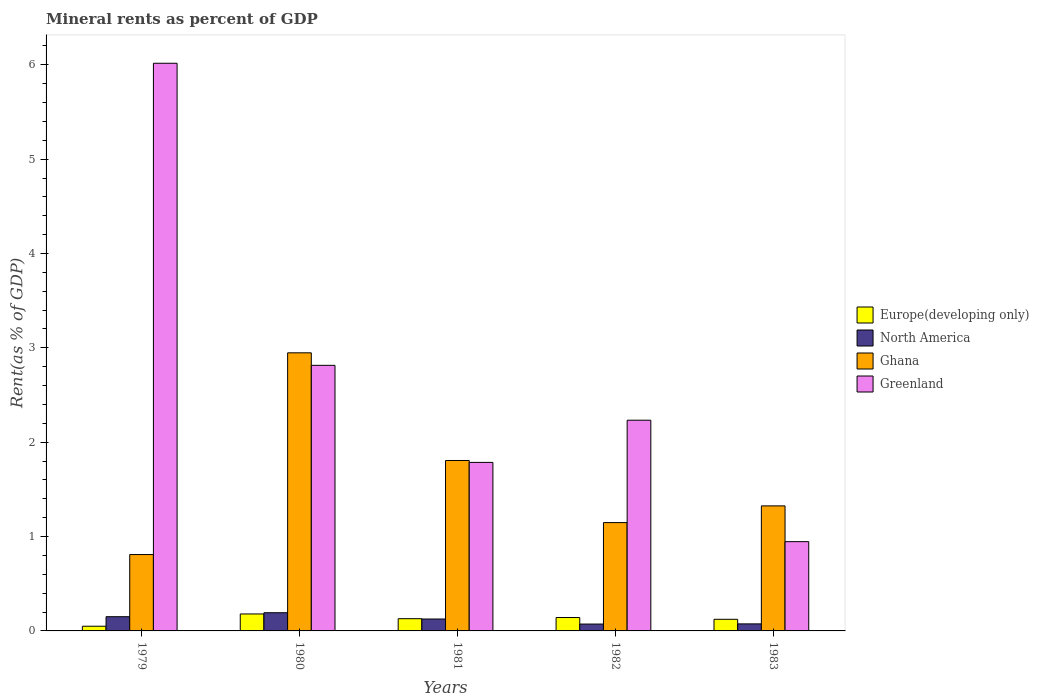How many groups of bars are there?
Keep it short and to the point. 5. How many bars are there on the 1st tick from the right?
Offer a terse response. 4. What is the mineral rent in North America in 1982?
Provide a succinct answer. 0.07. Across all years, what is the maximum mineral rent in Greenland?
Give a very brief answer. 6.02. Across all years, what is the minimum mineral rent in North America?
Ensure brevity in your answer.  0.07. In which year was the mineral rent in North America maximum?
Provide a succinct answer. 1980. In which year was the mineral rent in Europe(developing only) minimum?
Give a very brief answer. 1979. What is the total mineral rent in Ghana in the graph?
Offer a very short reply. 8.04. What is the difference between the mineral rent in North America in 1979 and that in 1983?
Make the answer very short. 0.08. What is the difference between the mineral rent in Greenland in 1982 and the mineral rent in Europe(developing only) in 1980?
Keep it short and to the point. 2.05. What is the average mineral rent in Greenland per year?
Provide a succinct answer. 2.76. In the year 1982, what is the difference between the mineral rent in Ghana and mineral rent in North America?
Keep it short and to the point. 1.08. In how many years, is the mineral rent in Greenland greater than 5.4 %?
Provide a short and direct response. 1. What is the ratio of the mineral rent in Greenland in 1980 to that in 1983?
Your answer should be very brief. 2.97. Is the difference between the mineral rent in Ghana in 1981 and 1983 greater than the difference between the mineral rent in North America in 1981 and 1983?
Ensure brevity in your answer.  Yes. What is the difference between the highest and the second highest mineral rent in Europe(developing only)?
Provide a short and direct response. 0.04. What is the difference between the highest and the lowest mineral rent in Greenland?
Your answer should be compact. 5.07. Is the sum of the mineral rent in Ghana in 1979 and 1983 greater than the maximum mineral rent in North America across all years?
Your answer should be very brief. Yes. What does the 3rd bar from the left in 1979 represents?
Your response must be concise. Ghana. Are all the bars in the graph horizontal?
Your response must be concise. No. Are the values on the major ticks of Y-axis written in scientific E-notation?
Provide a succinct answer. No. How many legend labels are there?
Your answer should be compact. 4. How are the legend labels stacked?
Ensure brevity in your answer.  Vertical. What is the title of the graph?
Offer a terse response. Mineral rents as percent of GDP. What is the label or title of the Y-axis?
Ensure brevity in your answer.  Rent(as % of GDP). What is the Rent(as % of GDP) in Europe(developing only) in 1979?
Your answer should be very brief. 0.05. What is the Rent(as % of GDP) of North America in 1979?
Keep it short and to the point. 0.15. What is the Rent(as % of GDP) in Ghana in 1979?
Keep it short and to the point. 0.81. What is the Rent(as % of GDP) in Greenland in 1979?
Provide a short and direct response. 6.02. What is the Rent(as % of GDP) in Europe(developing only) in 1980?
Provide a short and direct response. 0.18. What is the Rent(as % of GDP) in North America in 1980?
Keep it short and to the point. 0.19. What is the Rent(as % of GDP) in Ghana in 1980?
Your response must be concise. 2.95. What is the Rent(as % of GDP) in Greenland in 1980?
Give a very brief answer. 2.81. What is the Rent(as % of GDP) in Europe(developing only) in 1981?
Your answer should be very brief. 0.13. What is the Rent(as % of GDP) in North America in 1981?
Keep it short and to the point. 0.13. What is the Rent(as % of GDP) in Ghana in 1981?
Your answer should be compact. 1.81. What is the Rent(as % of GDP) of Greenland in 1981?
Make the answer very short. 1.79. What is the Rent(as % of GDP) in Europe(developing only) in 1982?
Keep it short and to the point. 0.14. What is the Rent(as % of GDP) of North America in 1982?
Offer a terse response. 0.07. What is the Rent(as % of GDP) of Ghana in 1982?
Make the answer very short. 1.15. What is the Rent(as % of GDP) of Greenland in 1982?
Keep it short and to the point. 2.23. What is the Rent(as % of GDP) in Europe(developing only) in 1983?
Make the answer very short. 0.12. What is the Rent(as % of GDP) of North America in 1983?
Provide a succinct answer. 0.07. What is the Rent(as % of GDP) of Ghana in 1983?
Keep it short and to the point. 1.33. What is the Rent(as % of GDP) of Greenland in 1983?
Your answer should be compact. 0.95. Across all years, what is the maximum Rent(as % of GDP) in Europe(developing only)?
Provide a short and direct response. 0.18. Across all years, what is the maximum Rent(as % of GDP) in North America?
Give a very brief answer. 0.19. Across all years, what is the maximum Rent(as % of GDP) of Ghana?
Make the answer very short. 2.95. Across all years, what is the maximum Rent(as % of GDP) of Greenland?
Make the answer very short. 6.02. Across all years, what is the minimum Rent(as % of GDP) of Europe(developing only)?
Provide a short and direct response. 0.05. Across all years, what is the minimum Rent(as % of GDP) of North America?
Offer a very short reply. 0.07. Across all years, what is the minimum Rent(as % of GDP) in Ghana?
Your answer should be very brief. 0.81. Across all years, what is the minimum Rent(as % of GDP) of Greenland?
Give a very brief answer. 0.95. What is the total Rent(as % of GDP) of Europe(developing only) in the graph?
Give a very brief answer. 0.62. What is the total Rent(as % of GDP) of North America in the graph?
Your answer should be very brief. 0.62. What is the total Rent(as % of GDP) of Ghana in the graph?
Keep it short and to the point. 8.04. What is the total Rent(as % of GDP) in Greenland in the graph?
Keep it short and to the point. 13.8. What is the difference between the Rent(as % of GDP) in Europe(developing only) in 1979 and that in 1980?
Your answer should be very brief. -0.13. What is the difference between the Rent(as % of GDP) in North America in 1979 and that in 1980?
Ensure brevity in your answer.  -0.04. What is the difference between the Rent(as % of GDP) in Ghana in 1979 and that in 1980?
Make the answer very short. -2.14. What is the difference between the Rent(as % of GDP) in Greenland in 1979 and that in 1980?
Your answer should be compact. 3.2. What is the difference between the Rent(as % of GDP) in Europe(developing only) in 1979 and that in 1981?
Keep it short and to the point. -0.08. What is the difference between the Rent(as % of GDP) of North America in 1979 and that in 1981?
Offer a very short reply. 0.02. What is the difference between the Rent(as % of GDP) in Ghana in 1979 and that in 1981?
Make the answer very short. -1. What is the difference between the Rent(as % of GDP) of Greenland in 1979 and that in 1981?
Give a very brief answer. 4.23. What is the difference between the Rent(as % of GDP) in Europe(developing only) in 1979 and that in 1982?
Keep it short and to the point. -0.09. What is the difference between the Rent(as % of GDP) of North America in 1979 and that in 1982?
Your answer should be compact. 0.08. What is the difference between the Rent(as % of GDP) in Ghana in 1979 and that in 1982?
Offer a very short reply. -0.34. What is the difference between the Rent(as % of GDP) in Greenland in 1979 and that in 1982?
Keep it short and to the point. 3.78. What is the difference between the Rent(as % of GDP) of Europe(developing only) in 1979 and that in 1983?
Provide a short and direct response. -0.07. What is the difference between the Rent(as % of GDP) in North America in 1979 and that in 1983?
Provide a short and direct response. 0.08. What is the difference between the Rent(as % of GDP) of Ghana in 1979 and that in 1983?
Ensure brevity in your answer.  -0.52. What is the difference between the Rent(as % of GDP) in Greenland in 1979 and that in 1983?
Your answer should be compact. 5.07. What is the difference between the Rent(as % of GDP) of Europe(developing only) in 1980 and that in 1981?
Offer a very short reply. 0.05. What is the difference between the Rent(as % of GDP) in North America in 1980 and that in 1981?
Make the answer very short. 0.07. What is the difference between the Rent(as % of GDP) in Ghana in 1980 and that in 1981?
Provide a short and direct response. 1.14. What is the difference between the Rent(as % of GDP) of Greenland in 1980 and that in 1981?
Provide a succinct answer. 1.03. What is the difference between the Rent(as % of GDP) in Europe(developing only) in 1980 and that in 1982?
Offer a terse response. 0.04. What is the difference between the Rent(as % of GDP) in North America in 1980 and that in 1982?
Give a very brief answer. 0.12. What is the difference between the Rent(as % of GDP) in Ghana in 1980 and that in 1982?
Give a very brief answer. 1.8. What is the difference between the Rent(as % of GDP) of Greenland in 1980 and that in 1982?
Ensure brevity in your answer.  0.58. What is the difference between the Rent(as % of GDP) in Europe(developing only) in 1980 and that in 1983?
Provide a short and direct response. 0.06. What is the difference between the Rent(as % of GDP) of North America in 1980 and that in 1983?
Make the answer very short. 0.12. What is the difference between the Rent(as % of GDP) of Ghana in 1980 and that in 1983?
Give a very brief answer. 1.62. What is the difference between the Rent(as % of GDP) in Greenland in 1980 and that in 1983?
Your response must be concise. 1.87. What is the difference between the Rent(as % of GDP) in Europe(developing only) in 1981 and that in 1982?
Your answer should be compact. -0.01. What is the difference between the Rent(as % of GDP) in North America in 1981 and that in 1982?
Give a very brief answer. 0.05. What is the difference between the Rent(as % of GDP) in Ghana in 1981 and that in 1982?
Make the answer very short. 0.66. What is the difference between the Rent(as % of GDP) in Greenland in 1981 and that in 1982?
Provide a succinct answer. -0.45. What is the difference between the Rent(as % of GDP) of Europe(developing only) in 1981 and that in 1983?
Your answer should be very brief. 0.01. What is the difference between the Rent(as % of GDP) of North America in 1981 and that in 1983?
Your answer should be very brief. 0.05. What is the difference between the Rent(as % of GDP) in Ghana in 1981 and that in 1983?
Provide a short and direct response. 0.48. What is the difference between the Rent(as % of GDP) in Greenland in 1981 and that in 1983?
Give a very brief answer. 0.84. What is the difference between the Rent(as % of GDP) in Europe(developing only) in 1982 and that in 1983?
Ensure brevity in your answer.  0.02. What is the difference between the Rent(as % of GDP) in North America in 1982 and that in 1983?
Your response must be concise. -0. What is the difference between the Rent(as % of GDP) of Ghana in 1982 and that in 1983?
Provide a short and direct response. -0.18. What is the difference between the Rent(as % of GDP) of Greenland in 1982 and that in 1983?
Offer a very short reply. 1.29. What is the difference between the Rent(as % of GDP) of Europe(developing only) in 1979 and the Rent(as % of GDP) of North America in 1980?
Ensure brevity in your answer.  -0.14. What is the difference between the Rent(as % of GDP) in Europe(developing only) in 1979 and the Rent(as % of GDP) in Ghana in 1980?
Keep it short and to the point. -2.9. What is the difference between the Rent(as % of GDP) in Europe(developing only) in 1979 and the Rent(as % of GDP) in Greenland in 1980?
Keep it short and to the point. -2.77. What is the difference between the Rent(as % of GDP) of North America in 1979 and the Rent(as % of GDP) of Ghana in 1980?
Offer a terse response. -2.8. What is the difference between the Rent(as % of GDP) in North America in 1979 and the Rent(as % of GDP) in Greenland in 1980?
Your answer should be very brief. -2.66. What is the difference between the Rent(as % of GDP) of Ghana in 1979 and the Rent(as % of GDP) of Greenland in 1980?
Your answer should be compact. -2.01. What is the difference between the Rent(as % of GDP) in Europe(developing only) in 1979 and the Rent(as % of GDP) in North America in 1981?
Provide a short and direct response. -0.08. What is the difference between the Rent(as % of GDP) of Europe(developing only) in 1979 and the Rent(as % of GDP) of Ghana in 1981?
Your answer should be very brief. -1.76. What is the difference between the Rent(as % of GDP) of Europe(developing only) in 1979 and the Rent(as % of GDP) of Greenland in 1981?
Make the answer very short. -1.74. What is the difference between the Rent(as % of GDP) in North America in 1979 and the Rent(as % of GDP) in Ghana in 1981?
Offer a terse response. -1.66. What is the difference between the Rent(as % of GDP) in North America in 1979 and the Rent(as % of GDP) in Greenland in 1981?
Provide a succinct answer. -1.64. What is the difference between the Rent(as % of GDP) of Ghana in 1979 and the Rent(as % of GDP) of Greenland in 1981?
Offer a very short reply. -0.98. What is the difference between the Rent(as % of GDP) in Europe(developing only) in 1979 and the Rent(as % of GDP) in North America in 1982?
Your answer should be compact. -0.02. What is the difference between the Rent(as % of GDP) of Europe(developing only) in 1979 and the Rent(as % of GDP) of Ghana in 1982?
Your response must be concise. -1.1. What is the difference between the Rent(as % of GDP) of Europe(developing only) in 1979 and the Rent(as % of GDP) of Greenland in 1982?
Your answer should be compact. -2.18. What is the difference between the Rent(as % of GDP) of North America in 1979 and the Rent(as % of GDP) of Ghana in 1982?
Your answer should be very brief. -1. What is the difference between the Rent(as % of GDP) in North America in 1979 and the Rent(as % of GDP) in Greenland in 1982?
Keep it short and to the point. -2.08. What is the difference between the Rent(as % of GDP) of Ghana in 1979 and the Rent(as % of GDP) of Greenland in 1982?
Provide a succinct answer. -1.42. What is the difference between the Rent(as % of GDP) of Europe(developing only) in 1979 and the Rent(as % of GDP) of North America in 1983?
Provide a succinct answer. -0.03. What is the difference between the Rent(as % of GDP) of Europe(developing only) in 1979 and the Rent(as % of GDP) of Ghana in 1983?
Keep it short and to the point. -1.28. What is the difference between the Rent(as % of GDP) of Europe(developing only) in 1979 and the Rent(as % of GDP) of Greenland in 1983?
Provide a short and direct response. -0.9. What is the difference between the Rent(as % of GDP) of North America in 1979 and the Rent(as % of GDP) of Ghana in 1983?
Offer a terse response. -1.17. What is the difference between the Rent(as % of GDP) of North America in 1979 and the Rent(as % of GDP) of Greenland in 1983?
Provide a succinct answer. -0.8. What is the difference between the Rent(as % of GDP) in Ghana in 1979 and the Rent(as % of GDP) in Greenland in 1983?
Keep it short and to the point. -0.14. What is the difference between the Rent(as % of GDP) in Europe(developing only) in 1980 and the Rent(as % of GDP) in North America in 1981?
Your response must be concise. 0.05. What is the difference between the Rent(as % of GDP) of Europe(developing only) in 1980 and the Rent(as % of GDP) of Ghana in 1981?
Provide a short and direct response. -1.63. What is the difference between the Rent(as % of GDP) in Europe(developing only) in 1980 and the Rent(as % of GDP) in Greenland in 1981?
Give a very brief answer. -1.61. What is the difference between the Rent(as % of GDP) of North America in 1980 and the Rent(as % of GDP) of Ghana in 1981?
Offer a terse response. -1.61. What is the difference between the Rent(as % of GDP) in North America in 1980 and the Rent(as % of GDP) in Greenland in 1981?
Your response must be concise. -1.59. What is the difference between the Rent(as % of GDP) in Ghana in 1980 and the Rent(as % of GDP) in Greenland in 1981?
Provide a short and direct response. 1.16. What is the difference between the Rent(as % of GDP) in Europe(developing only) in 1980 and the Rent(as % of GDP) in North America in 1982?
Your answer should be compact. 0.11. What is the difference between the Rent(as % of GDP) of Europe(developing only) in 1980 and the Rent(as % of GDP) of Ghana in 1982?
Provide a succinct answer. -0.97. What is the difference between the Rent(as % of GDP) of Europe(developing only) in 1980 and the Rent(as % of GDP) of Greenland in 1982?
Your answer should be compact. -2.05. What is the difference between the Rent(as % of GDP) in North America in 1980 and the Rent(as % of GDP) in Ghana in 1982?
Your response must be concise. -0.96. What is the difference between the Rent(as % of GDP) of North America in 1980 and the Rent(as % of GDP) of Greenland in 1982?
Provide a short and direct response. -2.04. What is the difference between the Rent(as % of GDP) of Ghana in 1980 and the Rent(as % of GDP) of Greenland in 1982?
Your answer should be compact. 0.71. What is the difference between the Rent(as % of GDP) in Europe(developing only) in 1980 and the Rent(as % of GDP) in North America in 1983?
Your answer should be compact. 0.11. What is the difference between the Rent(as % of GDP) of Europe(developing only) in 1980 and the Rent(as % of GDP) of Ghana in 1983?
Offer a terse response. -1.15. What is the difference between the Rent(as % of GDP) of Europe(developing only) in 1980 and the Rent(as % of GDP) of Greenland in 1983?
Your answer should be very brief. -0.77. What is the difference between the Rent(as % of GDP) in North America in 1980 and the Rent(as % of GDP) in Ghana in 1983?
Offer a terse response. -1.13. What is the difference between the Rent(as % of GDP) in North America in 1980 and the Rent(as % of GDP) in Greenland in 1983?
Your response must be concise. -0.75. What is the difference between the Rent(as % of GDP) of Ghana in 1980 and the Rent(as % of GDP) of Greenland in 1983?
Offer a terse response. 2. What is the difference between the Rent(as % of GDP) in Europe(developing only) in 1981 and the Rent(as % of GDP) in North America in 1982?
Provide a succinct answer. 0.06. What is the difference between the Rent(as % of GDP) of Europe(developing only) in 1981 and the Rent(as % of GDP) of Ghana in 1982?
Make the answer very short. -1.02. What is the difference between the Rent(as % of GDP) of Europe(developing only) in 1981 and the Rent(as % of GDP) of Greenland in 1982?
Your response must be concise. -2.1. What is the difference between the Rent(as % of GDP) of North America in 1981 and the Rent(as % of GDP) of Ghana in 1982?
Your answer should be compact. -1.02. What is the difference between the Rent(as % of GDP) of North America in 1981 and the Rent(as % of GDP) of Greenland in 1982?
Your answer should be very brief. -2.11. What is the difference between the Rent(as % of GDP) of Ghana in 1981 and the Rent(as % of GDP) of Greenland in 1982?
Provide a short and direct response. -0.43. What is the difference between the Rent(as % of GDP) in Europe(developing only) in 1981 and the Rent(as % of GDP) in North America in 1983?
Your answer should be very brief. 0.05. What is the difference between the Rent(as % of GDP) in Europe(developing only) in 1981 and the Rent(as % of GDP) in Ghana in 1983?
Provide a succinct answer. -1.2. What is the difference between the Rent(as % of GDP) of Europe(developing only) in 1981 and the Rent(as % of GDP) of Greenland in 1983?
Provide a succinct answer. -0.82. What is the difference between the Rent(as % of GDP) of North America in 1981 and the Rent(as % of GDP) of Ghana in 1983?
Keep it short and to the point. -1.2. What is the difference between the Rent(as % of GDP) of North America in 1981 and the Rent(as % of GDP) of Greenland in 1983?
Offer a very short reply. -0.82. What is the difference between the Rent(as % of GDP) of Ghana in 1981 and the Rent(as % of GDP) of Greenland in 1983?
Provide a succinct answer. 0.86. What is the difference between the Rent(as % of GDP) of Europe(developing only) in 1982 and the Rent(as % of GDP) of North America in 1983?
Your response must be concise. 0.07. What is the difference between the Rent(as % of GDP) in Europe(developing only) in 1982 and the Rent(as % of GDP) in Ghana in 1983?
Offer a very short reply. -1.18. What is the difference between the Rent(as % of GDP) in Europe(developing only) in 1982 and the Rent(as % of GDP) in Greenland in 1983?
Ensure brevity in your answer.  -0.8. What is the difference between the Rent(as % of GDP) in North America in 1982 and the Rent(as % of GDP) in Ghana in 1983?
Make the answer very short. -1.25. What is the difference between the Rent(as % of GDP) of North America in 1982 and the Rent(as % of GDP) of Greenland in 1983?
Keep it short and to the point. -0.87. What is the difference between the Rent(as % of GDP) in Ghana in 1982 and the Rent(as % of GDP) in Greenland in 1983?
Make the answer very short. 0.2. What is the average Rent(as % of GDP) of Europe(developing only) per year?
Keep it short and to the point. 0.12. What is the average Rent(as % of GDP) in North America per year?
Give a very brief answer. 0.12. What is the average Rent(as % of GDP) of Ghana per year?
Your response must be concise. 1.61. What is the average Rent(as % of GDP) of Greenland per year?
Keep it short and to the point. 2.76. In the year 1979, what is the difference between the Rent(as % of GDP) of Europe(developing only) and Rent(as % of GDP) of North America?
Your answer should be compact. -0.1. In the year 1979, what is the difference between the Rent(as % of GDP) of Europe(developing only) and Rent(as % of GDP) of Ghana?
Make the answer very short. -0.76. In the year 1979, what is the difference between the Rent(as % of GDP) of Europe(developing only) and Rent(as % of GDP) of Greenland?
Your answer should be compact. -5.97. In the year 1979, what is the difference between the Rent(as % of GDP) of North America and Rent(as % of GDP) of Ghana?
Provide a short and direct response. -0.66. In the year 1979, what is the difference between the Rent(as % of GDP) of North America and Rent(as % of GDP) of Greenland?
Your answer should be compact. -5.87. In the year 1979, what is the difference between the Rent(as % of GDP) in Ghana and Rent(as % of GDP) in Greenland?
Ensure brevity in your answer.  -5.21. In the year 1980, what is the difference between the Rent(as % of GDP) in Europe(developing only) and Rent(as % of GDP) in North America?
Provide a short and direct response. -0.01. In the year 1980, what is the difference between the Rent(as % of GDP) of Europe(developing only) and Rent(as % of GDP) of Ghana?
Ensure brevity in your answer.  -2.77. In the year 1980, what is the difference between the Rent(as % of GDP) of Europe(developing only) and Rent(as % of GDP) of Greenland?
Make the answer very short. -2.63. In the year 1980, what is the difference between the Rent(as % of GDP) in North America and Rent(as % of GDP) in Ghana?
Your response must be concise. -2.75. In the year 1980, what is the difference between the Rent(as % of GDP) of North America and Rent(as % of GDP) of Greenland?
Make the answer very short. -2.62. In the year 1980, what is the difference between the Rent(as % of GDP) of Ghana and Rent(as % of GDP) of Greenland?
Your response must be concise. 0.13. In the year 1981, what is the difference between the Rent(as % of GDP) in Europe(developing only) and Rent(as % of GDP) in North America?
Offer a terse response. 0. In the year 1981, what is the difference between the Rent(as % of GDP) in Europe(developing only) and Rent(as % of GDP) in Ghana?
Make the answer very short. -1.68. In the year 1981, what is the difference between the Rent(as % of GDP) in Europe(developing only) and Rent(as % of GDP) in Greenland?
Your answer should be compact. -1.66. In the year 1981, what is the difference between the Rent(as % of GDP) in North America and Rent(as % of GDP) in Ghana?
Your answer should be very brief. -1.68. In the year 1981, what is the difference between the Rent(as % of GDP) of North America and Rent(as % of GDP) of Greenland?
Provide a short and direct response. -1.66. In the year 1981, what is the difference between the Rent(as % of GDP) in Ghana and Rent(as % of GDP) in Greenland?
Give a very brief answer. 0.02. In the year 1982, what is the difference between the Rent(as % of GDP) in Europe(developing only) and Rent(as % of GDP) in North America?
Your response must be concise. 0.07. In the year 1982, what is the difference between the Rent(as % of GDP) in Europe(developing only) and Rent(as % of GDP) in Ghana?
Your answer should be compact. -1.01. In the year 1982, what is the difference between the Rent(as % of GDP) in Europe(developing only) and Rent(as % of GDP) in Greenland?
Offer a very short reply. -2.09. In the year 1982, what is the difference between the Rent(as % of GDP) in North America and Rent(as % of GDP) in Ghana?
Give a very brief answer. -1.08. In the year 1982, what is the difference between the Rent(as % of GDP) of North America and Rent(as % of GDP) of Greenland?
Give a very brief answer. -2.16. In the year 1982, what is the difference between the Rent(as % of GDP) of Ghana and Rent(as % of GDP) of Greenland?
Keep it short and to the point. -1.09. In the year 1983, what is the difference between the Rent(as % of GDP) of Europe(developing only) and Rent(as % of GDP) of North America?
Provide a short and direct response. 0.05. In the year 1983, what is the difference between the Rent(as % of GDP) of Europe(developing only) and Rent(as % of GDP) of Ghana?
Give a very brief answer. -1.2. In the year 1983, what is the difference between the Rent(as % of GDP) in Europe(developing only) and Rent(as % of GDP) in Greenland?
Provide a short and direct response. -0.82. In the year 1983, what is the difference between the Rent(as % of GDP) in North America and Rent(as % of GDP) in Ghana?
Keep it short and to the point. -1.25. In the year 1983, what is the difference between the Rent(as % of GDP) in North America and Rent(as % of GDP) in Greenland?
Keep it short and to the point. -0.87. In the year 1983, what is the difference between the Rent(as % of GDP) of Ghana and Rent(as % of GDP) of Greenland?
Give a very brief answer. 0.38. What is the ratio of the Rent(as % of GDP) of Europe(developing only) in 1979 to that in 1980?
Provide a succinct answer. 0.28. What is the ratio of the Rent(as % of GDP) in North America in 1979 to that in 1980?
Give a very brief answer. 0.78. What is the ratio of the Rent(as % of GDP) of Ghana in 1979 to that in 1980?
Keep it short and to the point. 0.27. What is the ratio of the Rent(as % of GDP) of Greenland in 1979 to that in 1980?
Offer a terse response. 2.14. What is the ratio of the Rent(as % of GDP) of Europe(developing only) in 1979 to that in 1981?
Make the answer very short. 0.38. What is the ratio of the Rent(as % of GDP) of North America in 1979 to that in 1981?
Provide a succinct answer. 1.19. What is the ratio of the Rent(as % of GDP) of Ghana in 1979 to that in 1981?
Your answer should be very brief. 0.45. What is the ratio of the Rent(as % of GDP) in Greenland in 1979 to that in 1981?
Provide a succinct answer. 3.37. What is the ratio of the Rent(as % of GDP) in Europe(developing only) in 1979 to that in 1982?
Make the answer very short. 0.35. What is the ratio of the Rent(as % of GDP) of North America in 1979 to that in 1982?
Provide a succinct answer. 2.07. What is the ratio of the Rent(as % of GDP) of Ghana in 1979 to that in 1982?
Offer a very short reply. 0.7. What is the ratio of the Rent(as % of GDP) in Greenland in 1979 to that in 1982?
Ensure brevity in your answer.  2.69. What is the ratio of the Rent(as % of GDP) of Europe(developing only) in 1979 to that in 1983?
Provide a succinct answer. 0.4. What is the ratio of the Rent(as % of GDP) in North America in 1979 to that in 1983?
Make the answer very short. 2.02. What is the ratio of the Rent(as % of GDP) of Ghana in 1979 to that in 1983?
Offer a terse response. 0.61. What is the ratio of the Rent(as % of GDP) in Greenland in 1979 to that in 1983?
Provide a short and direct response. 6.36. What is the ratio of the Rent(as % of GDP) of Europe(developing only) in 1980 to that in 1981?
Provide a short and direct response. 1.39. What is the ratio of the Rent(as % of GDP) of North America in 1980 to that in 1981?
Ensure brevity in your answer.  1.53. What is the ratio of the Rent(as % of GDP) of Ghana in 1980 to that in 1981?
Provide a short and direct response. 1.63. What is the ratio of the Rent(as % of GDP) in Greenland in 1980 to that in 1981?
Ensure brevity in your answer.  1.58. What is the ratio of the Rent(as % of GDP) of Europe(developing only) in 1980 to that in 1982?
Provide a short and direct response. 1.27. What is the ratio of the Rent(as % of GDP) of North America in 1980 to that in 1982?
Offer a terse response. 2.65. What is the ratio of the Rent(as % of GDP) of Ghana in 1980 to that in 1982?
Make the answer very short. 2.57. What is the ratio of the Rent(as % of GDP) in Greenland in 1980 to that in 1982?
Offer a terse response. 1.26. What is the ratio of the Rent(as % of GDP) of Europe(developing only) in 1980 to that in 1983?
Your response must be concise. 1.46. What is the ratio of the Rent(as % of GDP) in North America in 1980 to that in 1983?
Your response must be concise. 2.58. What is the ratio of the Rent(as % of GDP) of Ghana in 1980 to that in 1983?
Provide a short and direct response. 2.22. What is the ratio of the Rent(as % of GDP) in Greenland in 1980 to that in 1983?
Make the answer very short. 2.97. What is the ratio of the Rent(as % of GDP) in Europe(developing only) in 1981 to that in 1982?
Offer a terse response. 0.91. What is the ratio of the Rent(as % of GDP) of North America in 1981 to that in 1982?
Provide a succinct answer. 1.73. What is the ratio of the Rent(as % of GDP) of Ghana in 1981 to that in 1982?
Ensure brevity in your answer.  1.57. What is the ratio of the Rent(as % of GDP) of Greenland in 1981 to that in 1982?
Make the answer very short. 0.8. What is the ratio of the Rent(as % of GDP) in Europe(developing only) in 1981 to that in 1983?
Your answer should be compact. 1.05. What is the ratio of the Rent(as % of GDP) of North America in 1981 to that in 1983?
Your answer should be very brief. 1.69. What is the ratio of the Rent(as % of GDP) in Ghana in 1981 to that in 1983?
Your answer should be very brief. 1.36. What is the ratio of the Rent(as % of GDP) in Greenland in 1981 to that in 1983?
Provide a short and direct response. 1.89. What is the ratio of the Rent(as % of GDP) of Europe(developing only) in 1982 to that in 1983?
Give a very brief answer. 1.15. What is the ratio of the Rent(as % of GDP) of North America in 1982 to that in 1983?
Keep it short and to the point. 0.98. What is the ratio of the Rent(as % of GDP) of Ghana in 1982 to that in 1983?
Keep it short and to the point. 0.87. What is the ratio of the Rent(as % of GDP) of Greenland in 1982 to that in 1983?
Make the answer very short. 2.36. What is the difference between the highest and the second highest Rent(as % of GDP) of Europe(developing only)?
Your answer should be compact. 0.04. What is the difference between the highest and the second highest Rent(as % of GDP) in North America?
Make the answer very short. 0.04. What is the difference between the highest and the second highest Rent(as % of GDP) of Ghana?
Keep it short and to the point. 1.14. What is the difference between the highest and the second highest Rent(as % of GDP) of Greenland?
Offer a terse response. 3.2. What is the difference between the highest and the lowest Rent(as % of GDP) of Europe(developing only)?
Give a very brief answer. 0.13. What is the difference between the highest and the lowest Rent(as % of GDP) in North America?
Offer a terse response. 0.12. What is the difference between the highest and the lowest Rent(as % of GDP) in Ghana?
Offer a terse response. 2.14. What is the difference between the highest and the lowest Rent(as % of GDP) of Greenland?
Make the answer very short. 5.07. 